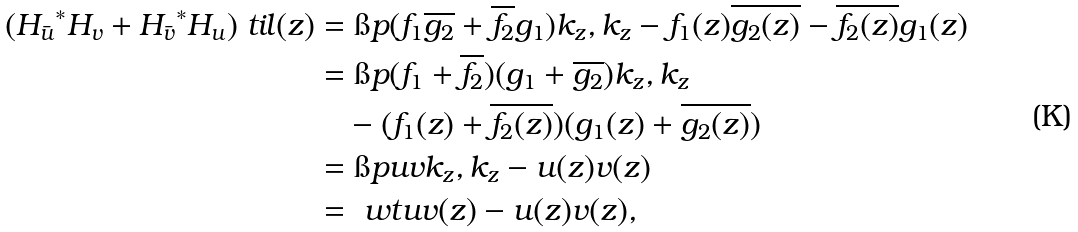Convert formula to latex. <formula><loc_0><loc_0><loc_500><loc_500>( { H _ { \bar { u } } } ^ { * } H _ { v } + { H _ { \bar { v } } } ^ { * } H _ { u } ) \ t i l ( z ) & = \i p { ( f _ { 1 } \overline { g _ { 2 } } + \overline { f _ { 2 } } g _ { 1 } ) k _ { z } , k _ { z } } - f _ { 1 } ( z ) \overline { g _ { 2 } ( z ) } - \overline { f _ { 2 } ( z ) } g _ { 1 } ( z ) \\ & = \i p { ( f _ { 1 } + \overline { f _ { 2 } } ) ( g _ { 1 } + \overline { g _ { 2 } } ) k _ { z } , k _ { z } } \\ & \quad - ( f _ { 1 } ( z ) + \overline { f _ { 2 } ( z ) } ) ( g _ { 1 } ( z ) + \overline { g _ { 2 } ( z ) } ) \\ & = \i p { u v k _ { z } , k _ { z } } - u ( z ) v ( z ) \\ & = \ w t { u v } ( z ) - u ( z ) v ( z ) ,</formula> 